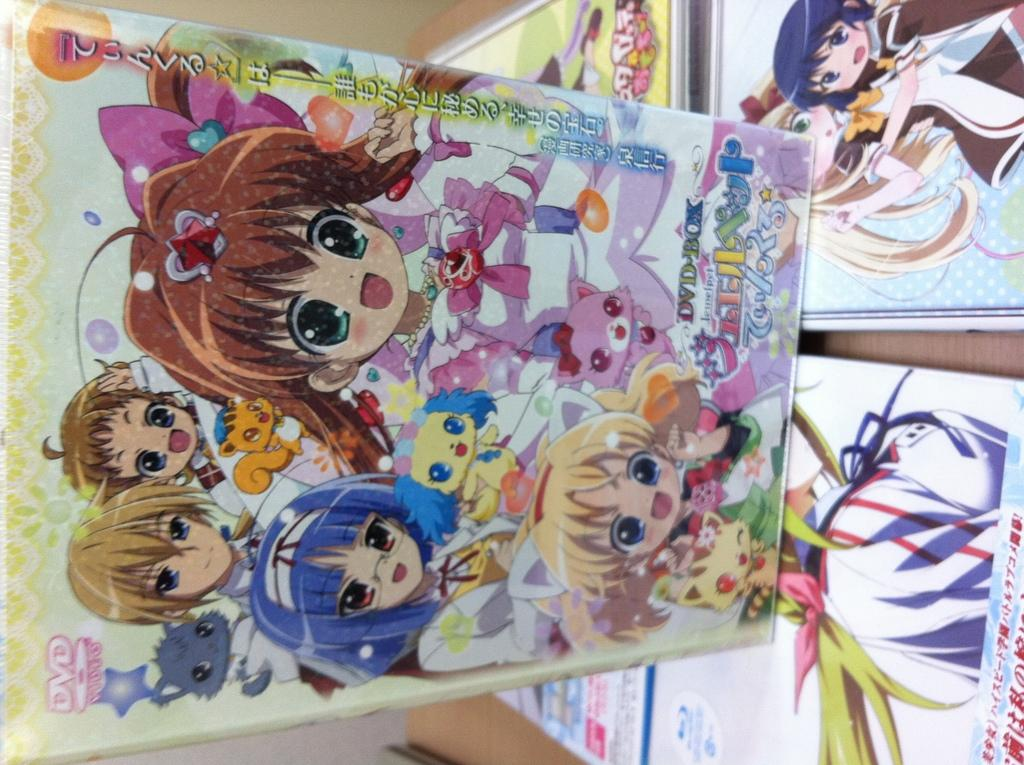Where was the image taken? The image is taken indoors. What can be seen in the background of the image? There is a wall in the background of the image. What is the main subject in the middle of the image? There is a book in the middle of the image. What furniture is visible on the right side of the image? There is a table on the right side of the image. How many books are on the table? There are a few books on the table. What type of current is flowing through the gate in the image? There is no gate or current present in the image. 